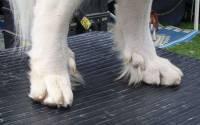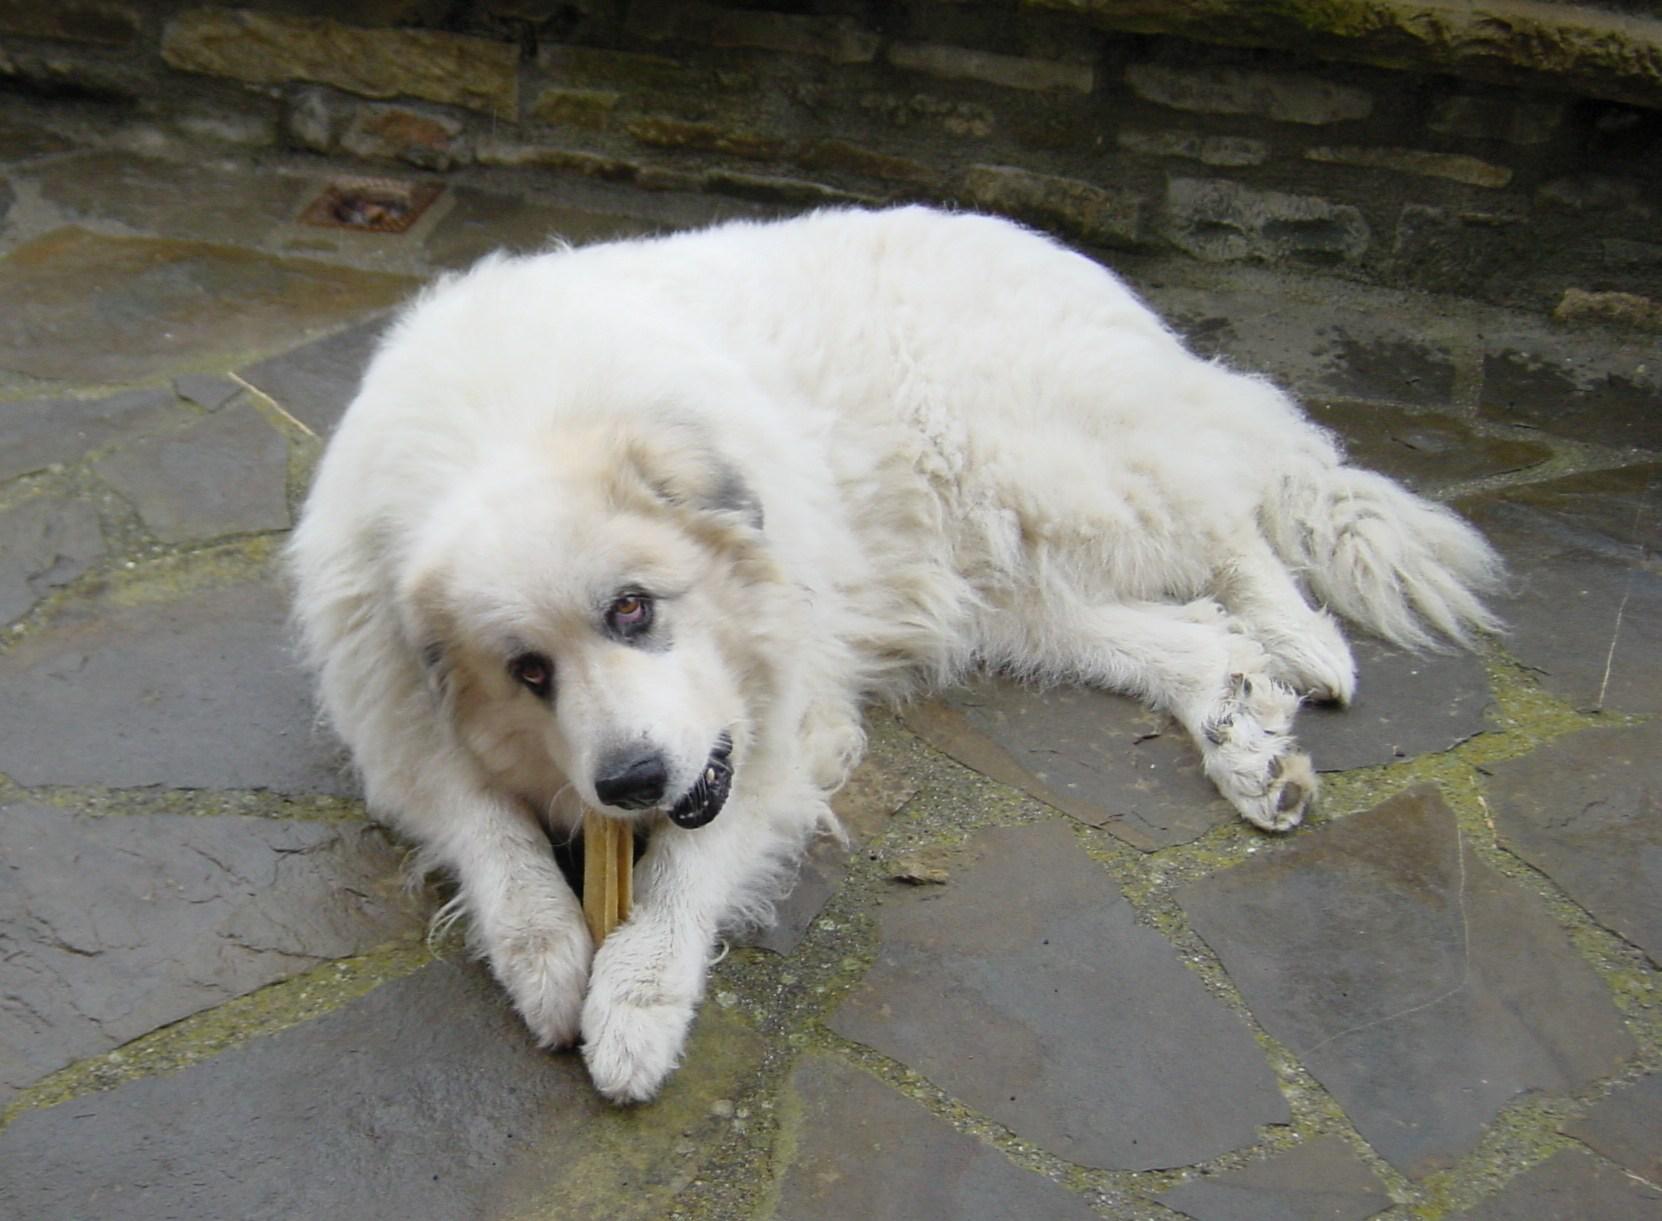The first image is the image on the left, the second image is the image on the right. Evaluate the accuracy of this statement regarding the images: "A girl wearing a blue shirt and sunglasses is sitting in between 2 large white dogs.". Is it true? Answer yes or no. No. 